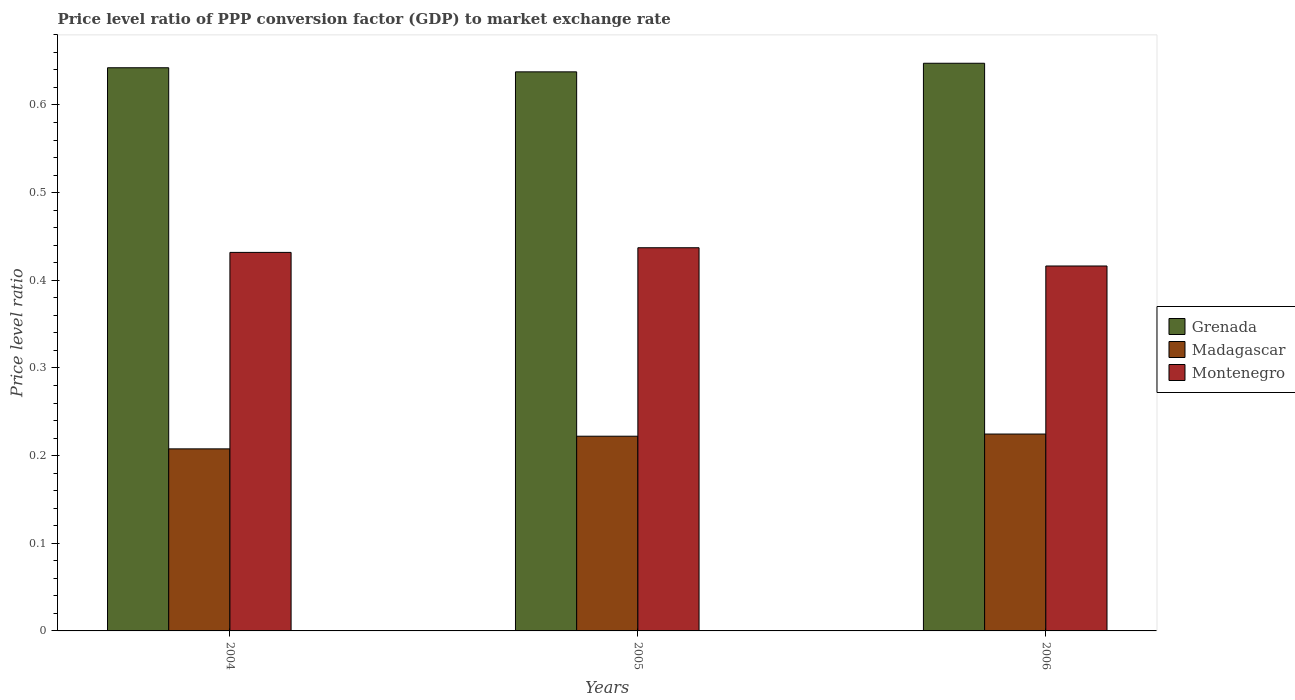How many different coloured bars are there?
Your response must be concise. 3. How many bars are there on the 2nd tick from the left?
Make the answer very short. 3. What is the label of the 1st group of bars from the left?
Keep it short and to the point. 2004. In how many cases, is the number of bars for a given year not equal to the number of legend labels?
Make the answer very short. 0. What is the price level ratio in Montenegro in 2005?
Your response must be concise. 0.44. Across all years, what is the maximum price level ratio in Grenada?
Provide a succinct answer. 0.65. Across all years, what is the minimum price level ratio in Grenada?
Your response must be concise. 0.64. What is the total price level ratio in Montenegro in the graph?
Offer a very short reply. 1.29. What is the difference between the price level ratio in Montenegro in 2004 and that in 2006?
Provide a short and direct response. 0.02. What is the difference between the price level ratio in Grenada in 2005 and the price level ratio in Madagascar in 2006?
Offer a very short reply. 0.41. What is the average price level ratio in Grenada per year?
Your answer should be very brief. 0.64. In the year 2006, what is the difference between the price level ratio in Grenada and price level ratio in Madagascar?
Provide a short and direct response. 0.42. In how many years, is the price level ratio in Madagascar greater than 0.32000000000000006?
Your answer should be very brief. 0. What is the ratio of the price level ratio in Grenada in 2004 to that in 2005?
Make the answer very short. 1.01. What is the difference between the highest and the second highest price level ratio in Madagascar?
Offer a terse response. 0. What is the difference between the highest and the lowest price level ratio in Madagascar?
Give a very brief answer. 0.02. Is the sum of the price level ratio in Madagascar in 2004 and 2005 greater than the maximum price level ratio in Grenada across all years?
Offer a terse response. No. What does the 2nd bar from the left in 2004 represents?
Your answer should be compact. Madagascar. What does the 3rd bar from the right in 2005 represents?
Your answer should be compact. Grenada. Is it the case that in every year, the sum of the price level ratio in Montenegro and price level ratio in Grenada is greater than the price level ratio in Madagascar?
Offer a terse response. Yes. How many bars are there?
Offer a terse response. 9. Are all the bars in the graph horizontal?
Provide a succinct answer. No. What is the difference between two consecutive major ticks on the Y-axis?
Offer a terse response. 0.1. Are the values on the major ticks of Y-axis written in scientific E-notation?
Provide a short and direct response. No. What is the title of the graph?
Your response must be concise. Price level ratio of PPP conversion factor (GDP) to market exchange rate. Does "Ukraine" appear as one of the legend labels in the graph?
Your answer should be compact. No. What is the label or title of the Y-axis?
Offer a terse response. Price level ratio. What is the Price level ratio in Grenada in 2004?
Provide a succinct answer. 0.64. What is the Price level ratio in Madagascar in 2004?
Your response must be concise. 0.21. What is the Price level ratio in Montenegro in 2004?
Your answer should be compact. 0.43. What is the Price level ratio in Grenada in 2005?
Make the answer very short. 0.64. What is the Price level ratio in Madagascar in 2005?
Your answer should be compact. 0.22. What is the Price level ratio of Montenegro in 2005?
Offer a terse response. 0.44. What is the Price level ratio in Grenada in 2006?
Keep it short and to the point. 0.65. What is the Price level ratio of Madagascar in 2006?
Offer a very short reply. 0.22. What is the Price level ratio in Montenegro in 2006?
Offer a terse response. 0.42. Across all years, what is the maximum Price level ratio of Grenada?
Give a very brief answer. 0.65. Across all years, what is the maximum Price level ratio in Madagascar?
Offer a terse response. 0.22. Across all years, what is the maximum Price level ratio of Montenegro?
Make the answer very short. 0.44. Across all years, what is the minimum Price level ratio in Grenada?
Ensure brevity in your answer.  0.64. Across all years, what is the minimum Price level ratio in Madagascar?
Your answer should be compact. 0.21. Across all years, what is the minimum Price level ratio of Montenegro?
Give a very brief answer. 0.42. What is the total Price level ratio in Grenada in the graph?
Make the answer very short. 1.93. What is the total Price level ratio of Madagascar in the graph?
Offer a very short reply. 0.65. What is the total Price level ratio of Montenegro in the graph?
Provide a succinct answer. 1.29. What is the difference between the Price level ratio of Grenada in 2004 and that in 2005?
Keep it short and to the point. 0. What is the difference between the Price level ratio in Madagascar in 2004 and that in 2005?
Your response must be concise. -0.01. What is the difference between the Price level ratio in Montenegro in 2004 and that in 2005?
Provide a short and direct response. -0.01. What is the difference between the Price level ratio of Grenada in 2004 and that in 2006?
Provide a short and direct response. -0.01. What is the difference between the Price level ratio in Madagascar in 2004 and that in 2006?
Offer a very short reply. -0.02. What is the difference between the Price level ratio in Montenegro in 2004 and that in 2006?
Your answer should be compact. 0.02. What is the difference between the Price level ratio of Grenada in 2005 and that in 2006?
Provide a short and direct response. -0.01. What is the difference between the Price level ratio in Madagascar in 2005 and that in 2006?
Keep it short and to the point. -0. What is the difference between the Price level ratio of Montenegro in 2005 and that in 2006?
Your answer should be compact. 0.02. What is the difference between the Price level ratio of Grenada in 2004 and the Price level ratio of Madagascar in 2005?
Your response must be concise. 0.42. What is the difference between the Price level ratio in Grenada in 2004 and the Price level ratio in Montenegro in 2005?
Ensure brevity in your answer.  0.21. What is the difference between the Price level ratio in Madagascar in 2004 and the Price level ratio in Montenegro in 2005?
Your answer should be compact. -0.23. What is the difference between the Price level ratio in Grenada in 2004 and the Price level ratio in Madagascar in 2006?
Provide a short and direct response. 0.42. What is the difference between the Price level ratio of Grenada in 2004 and the Price level ratio of Montenegro in 2006?
Your response must be concise. 0.23. What is the difference between the Price level ratio of Madagascar in 2004 and the Price level ratio of Montenegro in 2006?
Your answer should be very brief. -0.21. What is the difference between the Price level ratio in Grenada in 2005 and the Price level ratio in Madagascar in 2006?
Your response must be concise. 0.41. What is the difference between the Price level ratio in Grenada in 2005 and the Price level ratio in Montenegro in 2006?
Your answer should be compact. 0.22. What is the difference between the Price level ratio of Madagascar in 2005 and the Price level ratio of Montenegro in 2006?
Offer a terse response. -0.19. What is the average Price level ratio of Grenada per year?
Provide a succinct answer. 0.64. What is the average Price level ratio of Madagascar per year?
Provide a succinct answer. 0.22. What is the average Price level ratio of Montenegro per year?
Your answer should be very brief. 0.43. In the year 2004, what is the difference between the Price level ratio in Grenada and Price level ratio in Madagascar?
Your answer should be compact. 0.43. In the year 2004, what is the difference between the Price level ratio of Grenada and Price level ratio of Montenegro?
Your answer should be very brief. 0.21. In the year 2004, what is the difference between the Price level ratio in Madagascar and Price level ratio in Montenegro?
Your response must be concise. -0.22. In the year 2005, what is the difference between the Price level ratio in Grenada and Price level ratio in Madagascar?
Your response must be concise. 0.42. In the year 2005, what is the difference between the Price level ratio in Grenada and Price level ratio in Montenegro?
Keep it short and to the point. 0.2. In the year 2005, what is the difference between the Price level ratio in Madagascar and Price level ratio in Montenegro?
Offer a very short reply. -0.21. In the year 2006, what is the difference between the Price level ratio of Grenada and Price level ratio of Madagascar?
Your answer should be very brief. 0.42. In the year 2006, what is the difference between the Price level ratio in Grenada and Price level ratio in Montenegro?
Your answer should be very brief. 0.23. In the year 2006, what is the difference between the Price level ratio of Madagascar and Price level ratio of Montenegro?
Your answer should be compact. -0.19. What is the ratio of the Price level ratio in Grenada in 2004 to that in 2005?
Your answer should be very brief. 1.01. What is the ratio of the Price level ratio of Madagascar in 2004 to that in 2005?
Make the answer very short. 0.94. What is the ratio of the Price level ratio of Grenada in 2004 to that in 2006?
Your answer should be compact. 0.99. What is the ratio of the Price level ratio in Madagascar in 2004 to that in 2006?
Offer a very short reply. 0.92. What is the ratio of the Price level ratio in Montenegro in 2004 to that in 2006?
Provide a short and direct response. 1.04. What is the ratio of the Price level ratio of Grenada in 2005 to that in 2006?
Offer a very short reply. 0.98. What is the difference between the highest and the second highest Price level ratio in Grenada?
Your answer should be very brief. 0.01. What is the difference between the highest and the second highest Price level ratio of Madagascar?
Ensure brevity in your answer.  0. What is the difference between the highest and the second highest Price level ratio in Montenegro?
Make the answer very short. 0.01. What is the difference between the highest and the lowest Price level ratio in Grenada?
Make the answer very short. 0.01. What is the difference between the highest and the lowest Price level ratio in Madagascar?
Your answer should be very brief. 0.02. What is the difference between the highest and the lowest Price level ratio in Montenegro?
Provide a short and direct response. 0.02. 